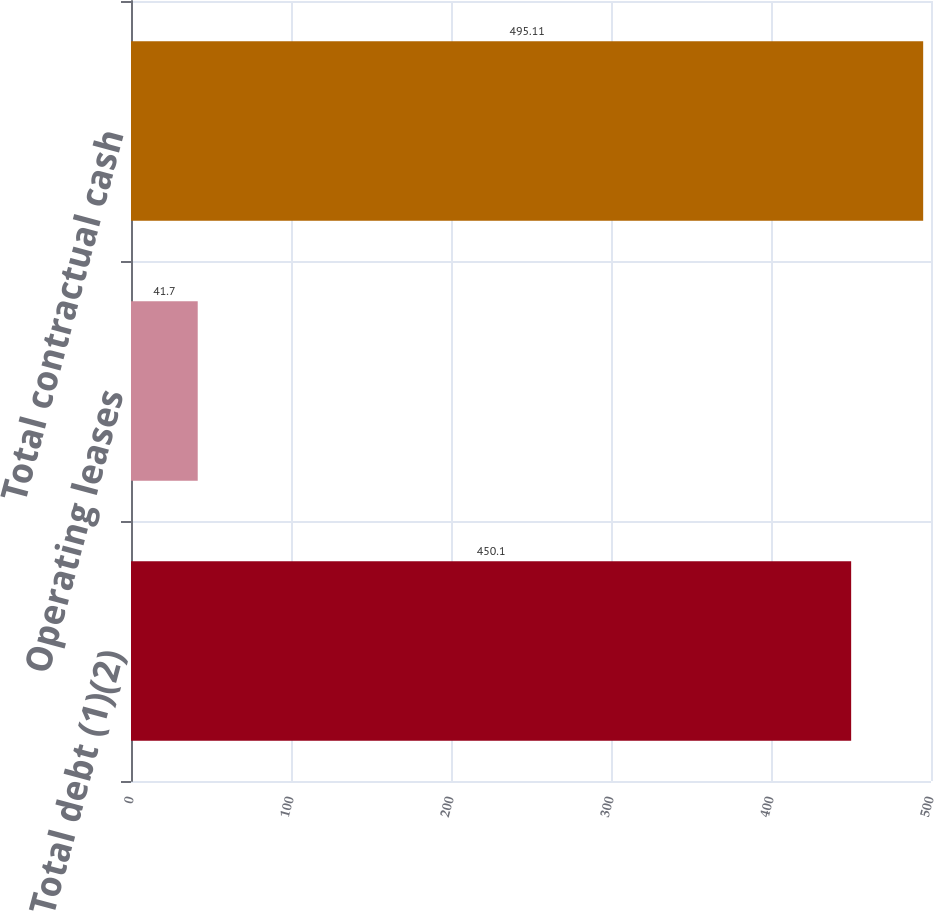Convert chart. <chart><loc_0><loc_0><loc_500><loc_500><bar_chart><fcel>Total debt (1)(2)<fcel>Operating leases<fcel>Total contractual cash<nl><fcel>450.1<fcel>41.7<fcel>495.11<nl></chart> 